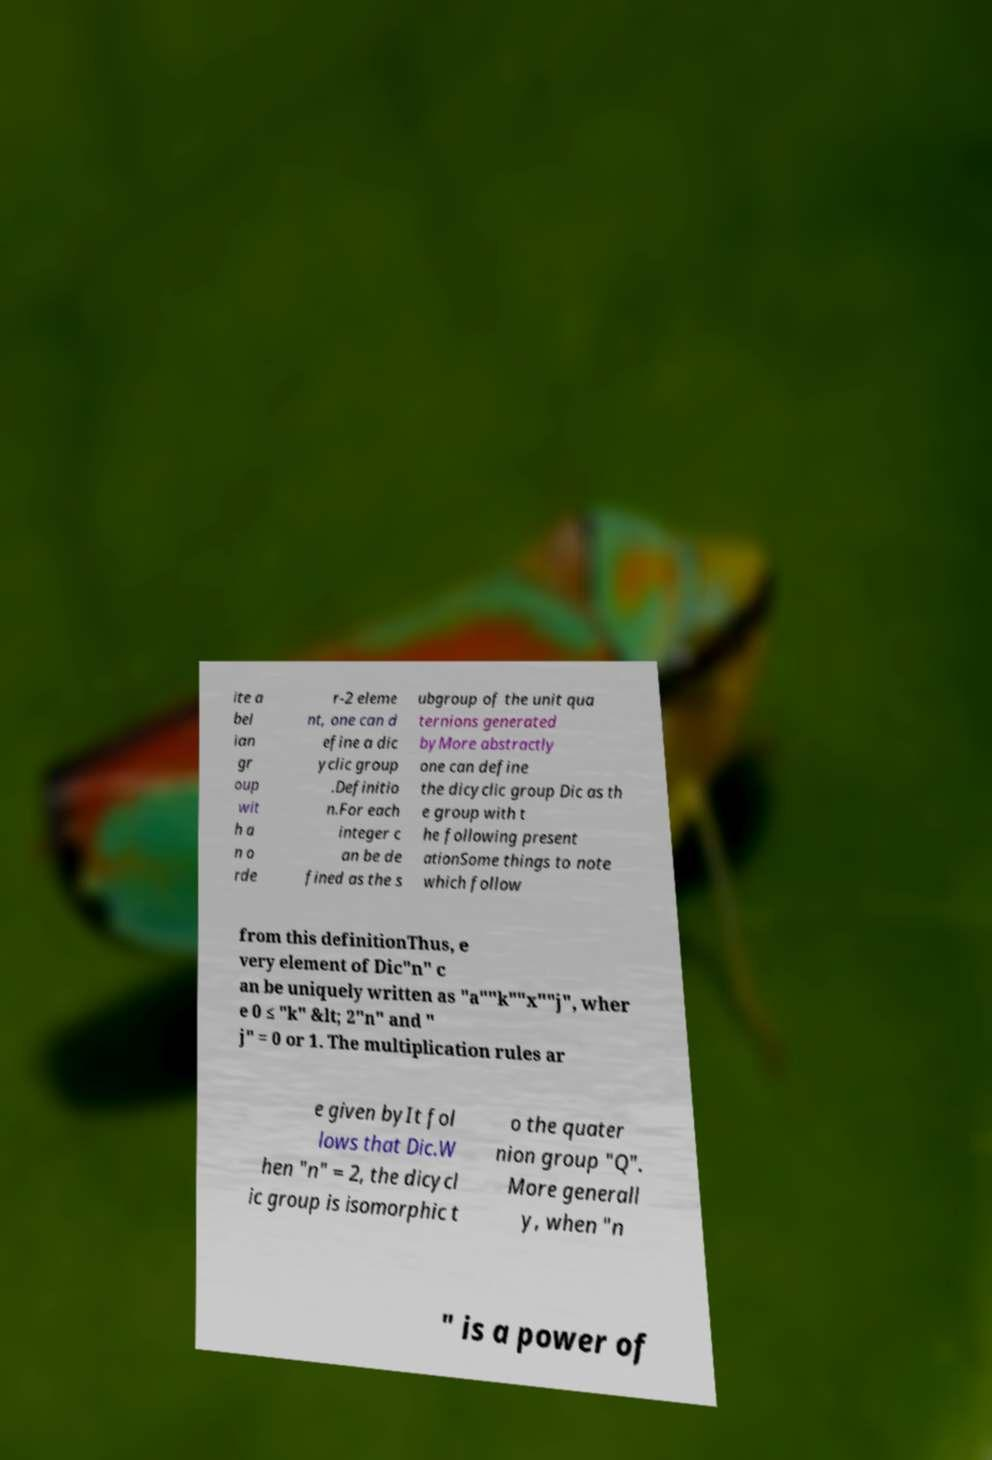Please identify and transcribe the text found in this image. ite a bel ian gr oup wit h a n o rde r-2 eleme nt, one can d efine a dic yclic group .Definitio n.For each integer c an be de fined as the s ubgroup of the unit qua ternions generated byMore abstractly one can define the dicyclic group Dic as th e group with t he following present ationSome things to note which follow from this definitionThus, e very element of Dic"n" c an be uniquely written as "a""k""x""j", wher e 0 ≤ "k" &lt; 2"n" and " j" = 0 or 1. The multiplication rules ar e given byIt fol lows that Dic.W hen "n" = 2, the dicycl ic group is isomorphic t o the quater nion group "Q". More generall y, when "n " is a power of 